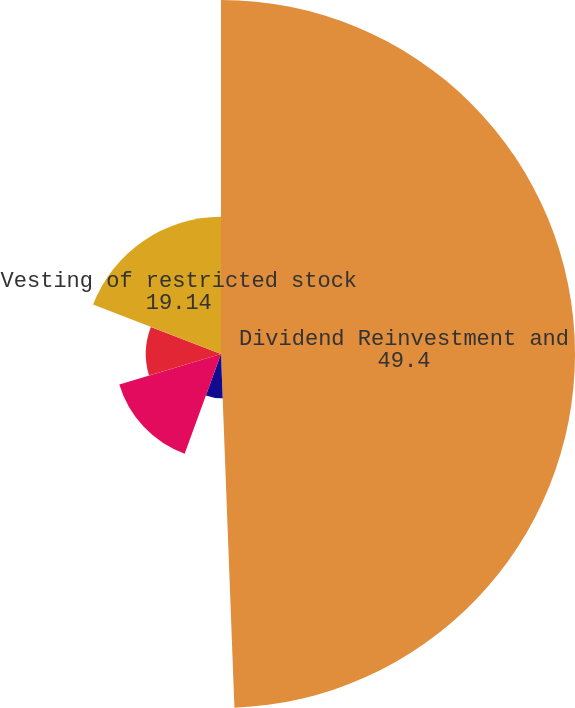<chart> <loc_0><loc_0><loc_500><loc_500><pie_chart><fcel>Dividend Reinvestment and<fcel>Conversion of DownREIT units<fcel>Exercise of stock options<fcel>Restricted stock awards (1)<fcel>Vesting of restricted stock<nl><fcel>49.4%<fcel>6.17%<fcel>14.81%<fcel>10.49%<fcel>19.14%<nl></chart> 